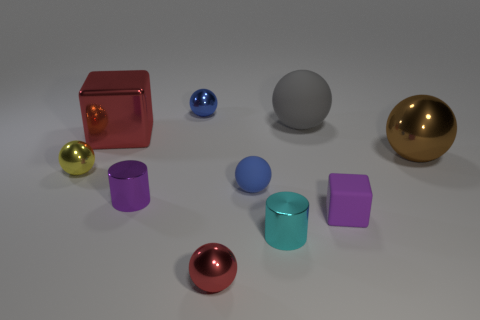Subtract all yellow spheres. How many spheres are left? 5 Subtract all yellow blocks. How many blue spheres are left? 2 Subtract all yellow balls. How many balls are left? 5 Subtract 4 spheres. How many spheres are left? 2 Subtract all cylinders. How many objects are left? 8 Subtract all red spheres. Subtract all brown cubes. How many spheres are left? 5 Add 1 small blue metal objects. How many small blue metal objects exist? 2 Subtract 1 purple cylinders. How many objects are left? 9 Subtract all tiny purple cylinders. Subtract all gray matte spheres. How many objects are left? 8 Add 4 big things. How many big things are left? 7 